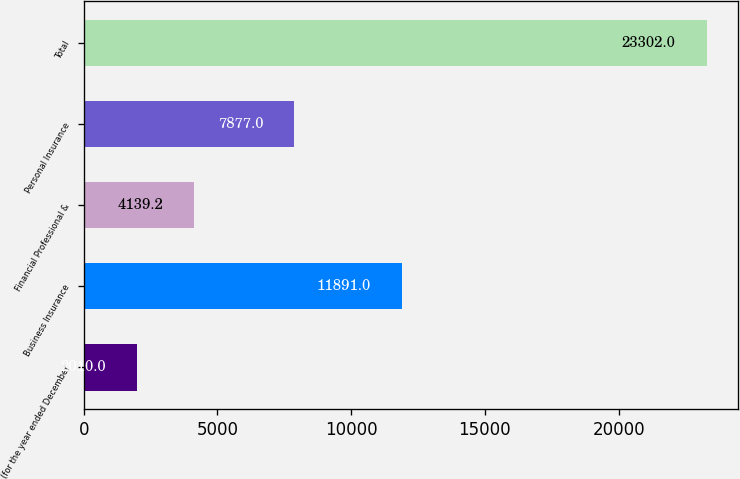<chart> <loc_0><loc_0><loc_500><loc_500><bar_chart><fcel>(for the year ended December<fcel>Business Insurance<fcel>Financial Professional &<fcel>Personal Insurance<fcel>Total<nl><fcel>2010<fcel>11891<fcel>4139.2<fcel>7877<fcel>23302<nl></chart> 